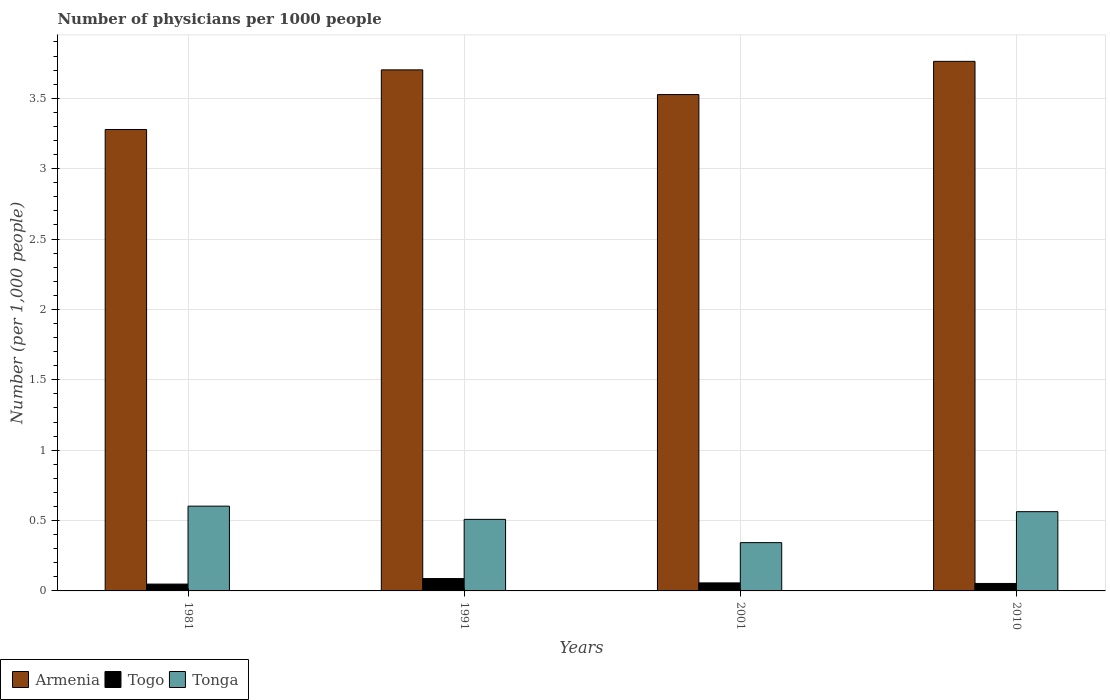How many groups of bars are there?
Provide a succinct answer. 4. Are the number of bars on each tick of the X-axis equal?
Ensure brevity in your answer.  Yes. How many bars are there on the 4th tick from the right?
Give a very brief answer. 3. What is the label of the 2nd group of bars from the left?
Make the answer very short. 1991. What is the number of physicians in Togo in 1991?
Give a very brief answer. 0.09. Across all years, what is the maximum number of physicians in Togo?
Make the answer very short. 0.09. Across all years, what is the minimum number of physicians in Tonga?
Your answer should be compact. 0.34. In which year was the number of physicians in Armenia maximum?
Provide a succinct answer. 2010. In which year was the number of physicians in Armenia minimum?
Give a very brief answer. 1981. What is the total number of physicians in Togo in the graph?
Provide a short and direct response. 0.25. What is the difference between the number of physicians in Armenia in 1981 and that in 2001?
Your answer should be very brief. -0.25. What is the difference between the number of physicians in Togo in 2001 and the number of physicians in Tonga in 1991?
Give a very brief answer. -0.45. What is the average number of physicians in Tonga per year?
Offer a very short reply. 0.5. In the year 2001, what is the difference between the number of physicians in Togo and number of physicians in Armenia?
Keep it short and to the point. -3.47. What is the ratio of the number of physicians in Armenia in 1991 to that in 2001?
Make the answer very short. 1.05. Is the number of physicians in Armenia in 1981 less than that in 2001?
Provide a succinct answer. Yes. Is the difference between the number of physicians in Togo in 1981 and 1991 greater than the difference between the number of physicians in Armenia in 1981 and 1991?
Your response must be concise. Yes. What is the difference between the highest and the second highest number of physicians in Armenia?
Ensure brevity in your answer.  0.06. What is the difference between the highest and the lowest number of physicians in Armenia?
Provide a succinct answer. 0.48. In how many years, is the number of physicians in Tonga greater than the average number of physicians in Tonga taken over all years?
Make the answer very short. 3. Is the sum of the number of physicians in Togo in 1991 and 2001 greater than the maximum number of physicians in Tonga across all years?
Your answer should be compact. No. What does the 3rd bar from the left in 2010 represents?
Your answer should be very brief. Tonga. What does the 2nd bar from the right in 1991 represents?
Ensure brevity in your answer.  Togo. How many bars are there?
Your answer should be compact. 12. Are the values on the major ticks of Y-axis written in scientific E-notation?
Provide a short and direct response. No. How many legend labels are there?
Make the answer very short. 3. How are the legend labels stacked?
Offer a terse response. Horizontal. What is the title of the graph?
Give a very brief answer. Number of physicians per 1000 people. Does "North America" appear as one of the legend labels in the graph?
Offer a terse response. No. What is the label or title of the Y-axis?
Ensure brevity in your answer.  Number (per 1,0 people). What is the Number (per 1,000 people) of Armenia in 1981?
Your response must be concise. 3.28. What is the Number (per 1,000 people) of Togo in 1981?
Provide a short and direct response. 0.05. What is the Number (per 1,000 people) in Tonga in 1981?
Your response must be concise. 0.6. What is the Number (per 1,000 people) in Armenia in 1991?
Provide a short and direct response. 3.7. What is the Number (per 1,000 people) in Togo in 1991?
Offer a very short reply. 0.09. What is the Number (per 1,000 people) of Tonga in 1991?
Your answer should be compact. 0.51. What is the Number (per 1,000 people) of Armenia in 2001?
Ensure brevity in your answer.  3.53. What is the Number (per 1,000 people) in Togo in 2001?
Ensure brevity in your answer.  0.06. What is the Number (per 1,000 people) in Tonga in 2001?
Your answer should be very brief. 0.34. What is the Number (per 1,000 people) in Armenia in 2010?
Your answer should be compact. 3.76. What is the Number (per 1,000 people) of Togo in 2010?
Offer a very short reply. 0.05. What is the Number (per 1,000 people) in Tonga in 2010?
Your response must be concise. 0.56. Across all years, what is the maximum Number (per 1,000 people) of Armenia?
Offer a very short reply. 3.76. Across all years, what is the maximum Number (per 1,000 people) in Togo?
Provide a short and direct response. 0.09. Across all years, what is the maximum Number (per 1,000 people) in Tonga?
Provide a short and direct response. 0.6. Across all years, what is the minimum Number (per 1,000 people) in Armenia?
Your answer should be very brief. 3.28. Across all years, what is the minimum Number (per 1,000 people) of Togo?
Your response must be concise. 0.05. Across all years, what is the minimum Number (per 1,000 people) of Tonga?
Your response must be concise. 0.34. What is the total Number (per 1,000 people) of Armenia in the graph?
Keep it short and to the point. 14.27. What is the total Number (per 1,000 people) in Togo in the graph?
Make the answer very short. 0.25. What is the total Number (per 1,000 people) in Tonga in the graph?
Provide a succinct answer. 2.02. What is the difference between the Number (per 1,000 people) of Armenia in 1981 and that in 1991?
Give a very brief answer. -0.42. What is the difference between the Number (per 1,000 people) in Togo in 1981 and that in 1991?
Your response must be concise. -0.04. What is the difference between the Number (per 1,000 people) of Tonga in 1981 and that in 1991?
Make the answer very short. 0.09. What is the difference between the Number (per 1,000 people) of Armenia in 1981 and that in 2001?
Offer a terse response. -0.25. What is the difference between the Number (per 1,000 people) in Togo in 1981 and that in 2001?
Keep it short and to the point. -0.01. What is the difference between the Number (per 1,000 people) of Tonga in 1981 and that in 2001?
Provide a short and direct response. 0.26. What is the difference between the Number (per 1,000 people) of Armenia in 1981 and that in 2010?
Provide a succinct answer. -0.48. What is the difference between the Number (per 1,000 people) in Togo in 1981 and that in 2010?
Offer a terse response. -0. What is the difference between the Number (per 1,000 people) in Tonga in 1981 and that in 2010?
Your answer should be compact. 0.04. What is the difference between the Number (per 1,000 people) of Armenia in 1991 and that in 2001?
Keep it short and to the point. 0.18. What is the difference between the Number (per 1,000 people) of Togo in 1991 and that in 2001?
Offer a very short reply. 0.03. What is the difference between the Number (per 1,000 people) of Tonga in 1991 and that in 2001?
Ensure brevity in your answer.  0.17. What is the difference between the Number (per 1,000 people) of Armenia in 1991 and that in 2010?
Offer a terse response. -0.06. What is the difference between the Number (per 1,000 people) of Togo in 1991 and that in 2010?
Offer a terse response. 0.03. What is the difference between the Number (per 1,000 people) of Tonga in 1991 and that in 2010?
Give a very brief answer. -0.05. What is the difference between the Number (per 1,000 people) in Armenia in 2001 and that in 2010?
Give a very brief answer. -0.24. What is the difference between the Number (per 1,000 people) in Togo in 2001 and that in 2010?
Your answer should be compact. 0. What is the difference between the Number (per 1,000 people) in Tonga in 2001 and that in 2010?
Ensure brevity in your answer.  -0.22. What is the difference between the Number (per 1,000 people) in Armenia in 1981 and the Number (per 1,000 people) in Togo in 1991?
Offer a very short reply. 3.19. What is the difference between the Number (per 1,000 people) of Armenia in 1981 and the Number (per 1,000 people) of Tonga in 1991?
Offer a very short reply. 2.77. What is the difference between the Number (per 1,000 people) of Togo in 1981 and the Number (per 1,000 people) of Tonga in 1991?
Make the answer very short. -0.46. What is the difference between the Number (per 1,000 people) of Armenia in 1981 and the Number (per 1,000 people) of Togo in 2001?
Your response must be concise. 3.22. What is the difference between the Number (per 1,000 people) in Armenia in 1981 and the Number (per 1,000 people) in Tonga in 2001?
Keep it short and to the point. 2.93. What is the difference between the Number (per 1,000 people) of Togo in 1981 and the Number (per 1,000 people) of Tonga in 2001?
Your answer should be very brief. -0.29. What is the difference between the Number (per 1,000 people) in Armenia in 1981 and the Number (per 1,000 people) in Togo in 2010?
Make the answer very short. 3.22. What is the difference between the Number (per 1,000 people) in Armenia in 1981 and the Number (per 1,000 people) in Tonga in 2010?
Ensure brevity in your answer.  2.71. What is the difference between the Number (per 1,000 people) of Togo in 1981 and the Number (per 1,000 people) of Tonga in 2010?
Ensure brevity in your answer.  -0.51. What is the difference between the Number (per 1,000 people) in Armenia in 1991 and the Number (per 1,000 people) in Togo in 2001?
Keep it short and to the point. 3.64. What is the difference between the Number (per 1,000 people) in Armenia in 1991 and the Number (per 1,000 people) in Tonga in 2001?
Offer a very short reply. 3.36. What is the difference between the Number (per 1,000 people) of Togo in 1991 and the Number (per 1,000 people) of Tonga in 2001?
Make the answer very short. -0.26. What is the difference between the Number (per 1,000 people) in Armenia in 1991 and the Number (per 1,000 people) in Togo in 2010?
Make the answer very short. 3.65. What is the difference between the Number (per 1,000 people) of Armenia in 1991 and the Number (per 1,000 people) of Tonga in 2010?
Your answer should be very brief. 3.14. What is the difference between the Number (per 1,000 people) in Togo in 1991 and the Number (per 1,000 people) in Tonga in 2010?
Make the answer very short. -0.48. What is the difference between the Number (per 1,000 people) in Armenia in 2001 and the Number (per 1,000 people) in Togo in 2010?
Provide a short and direct response. 3.47. What is the difference between the Number (per 1,000 people) of Armenia in 2001 and the Number (per 1,000 people) of Tonga in 2010?
Your answer should be compact. 2.96. What is the difference between the Number (per 1,000 people) in Togo in 2001 and the Number (per 1,000 people) in Tonga in 2010?
Your response must be concise. -0.51. What is the average Number (per 1,000 people) in Armenia per year?
Make the answer very short. 3.57. What is the average Number (per 1,000 people) in Togo per year?
Offer a terse response. 0.06. What is the average Number (per 1,000 people) of Tonga per year?
Ensure brevity in your answer.  0.5. In the year 1981, what is the difference between the Number (per 1,000 people) in Armenia and Number (per 1,000 people) in Togo?
Your response must be concise. 3.23. In the year 1981, what is the difference between the Number (per 1,000 people) of Armenia and Number (per 1,000 people) of Tonga?
Your answer should be very brief. 2.68. In the year 1981, what is the difference between the Number (per 1,000 people) of Togo and Number (per 1,000 people) of Tonga?
Make the answer very short. -0.55. In the year 1991, what is the difference between the Number (per 1,000 people) in Armenia and Number (per 1,000 people) in Togo?
Offer a terse response. 3.61. In the year 1991, what is the difference between the Number (per 1,000 people) in Armenia and Number (per 1,000 people) in Tonga?
Provide a short and direct response. 3.19. In the year 1991, what is the difference between the Number (per 1,000 people) of Togo and Number (per 1,000 people) of Tonga?
Your answer should be compact. -0.42. In the year 2001, what is the difference between the Number (per 1,000 people) of Armenia and Number (per 1,000 people) of Togo?
Your response must be concise. 3.47. In the year 2001, what is the difference between the Number (per 1,000 people) of Armenia and Number (per 1,000 people) of Tonga?
Ensure brevity in your answer.  3.18. In the year 2001, what is the difference between the Number (per 1,000 people) of Togo and Number (per 1,000 people) of Tonga?
Make the answer very short. -0.29. In the year 2010, what is the difference between the Number (per 1,000 people) of Armenia and Number (per 1,000 people) of Togo?
Offer a terse response. 3.71. In the year 2010, what is the difference between the Number (per 1,000 people) of Armenia and Number (per 1,000 people) of Tonga?
Your response must be concise. 3.2. In the year 2010, what is the difference between the Number (per 1,000 people) of Togo and Number (per 1,000 people) of Tonga?
Offer a very short reply. -0.51. What is the ratio of the Number (per 1,000 people) in Armenia in 1981 to that in 1991?
Offer a terse response. 0.89. What is the ratio of the Number (per 1,000 people) of Togo in 1981 to that in 1991?
Your answer should be very brief. 0.55. What is the ratio of the Number (per 1,000 people) in Tonga in 1981 to that in 1991?
Your answer should be very brief. 1.18. What is the ratio of the Number (per 1,000 people) of Armenia in 1981 to that in 2001?
Your answer should be compact. 0.93. What is the ratio of the Number (per 1,000 people) of Togo in 1981 to that in 2001?
Offer a very short reply. 0.85. What is the ratio of the Number (per 1,000 people) in Tonga in 1981 to that in 2001?
Your answer should be compact. 1.76. What is the ratio of the Number (per 1,000 people) in Armenia in 1981 to that in 2010?
Provide a succinct answer. 0.87. What is the ratio of the Number (per 1,000 people) in Togo in 1981 to that in 2010?
Offer a very short reply. 0.92. What is the ratio of the Number (per 1,000 people) of Tonga in 1981 to that in 2010?
Offer a terse response. 1.07. What is the ratio of the Number (per 1,000 people) in Armenia in 1991 to that in 2001?
Keep it short and to the point. 1.05. What is the ratio of the Number (per 1,000 people) of Togo in 1991 to that in 2001?
Offer a terse response. 1.54. What is the ratio of the Number (per 1,000 people) in Tonga in 1991 to that in 2001?
Your answer should be very brief. 1.48. What is the ratio of the Number (per 1,000 people) in Armenia in 1991 to that in 2010?
Offer a very short reply. 0.98. What is the ratio of the Number (per 1,000 people) in Togo in 1991 to that in 2010?
Your response must be concise. 1.66. What is the ratio of the Number (per 1,000 people) in Tonga in 1991 to that in 2010?
Give a very brief answer. 0.9. What is the ratio of the Number (per 1,000 people) of Armenia in 2001 to that in 2010?
Your answer should be compact. 0.94. What is the ratio of the Number (per 1,000 people) in Togo in 2001 to that in 2010?
Your answer should be very brief. 1.08. What is the ratio of the Number (per 1,000 people) of Tonga in 2001 to that in 2010?
Your answer should be compact. 0.61. What is the difference between the highest and the second highest Number (per 1,000 people) of Armenia?
Your response must be concise. 0.06. What is the difference between the highest and the second highest Number (per 1,000 people) of Togo?
Your answer should be very brief. 0.03. What is the difference between the highest and the second highest Number (per 1,000 people) in Tonga?
Offer a terse response. 0.04. What is the difference between the highest and the lowest Number (per 1,000 people) in Armenia?
Provide a short and direct response. 0.48. What is the difference between the highest and the lowest Number (per 1,000 people) of Togo?
Ensure brevity in your answer.  0.04. What is the difference between the highest and the lowest Number (per 1,000 people) in Tonga?
Your response must be concise. 0.26. 